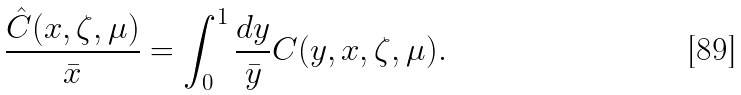<formula> <loc_0><loc_0><loc_500><loc_500>\frac { \hat { C } ( x , \zeta , \mu ) } { \bar { x } } = \int _ { 0 } ^ { 1 } \frac { d y } { \bar { y } } C ( y , x , \zeta , \mu ) .</formula> 